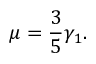<formula> <loc_0><loc_0><loc_500><loc_500>\mu = \frac { 3 } { 5 } \gamma _ { 1 } .</formula> 